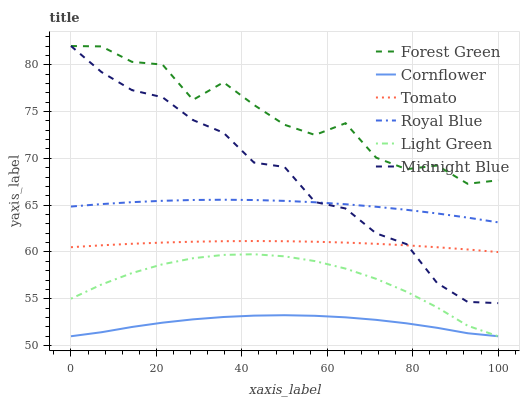Does Cornflower have the minimum area under the curve?
Answer yes or no. Yes. Does Forest Green have the maximum area under the curve?
Answer yes or no. Yes. Does Midnight Blue have the minimum area under the curve?
Answer yes or no. No. Does Midnight Blue have the maximum area under the curve?
Answer yes or no. No. Is Tomato the smoothest?
Answer yes or no. Yes. Is Forest Green the roughest?
Answer yes or no. Yes. Is Cornflower the smoothest?
Answer yes or no. No. Is Cornflower the roughest?
Answer yes or no. No. Does Midnight Blue have the lowest value?
Answer yes or no. No. Does Forest Green have the highest value?
Answer yes or no. Yes. Does Cornflower have the highest value?
Answer yes or no. No. Is Cornflower less than Royal Blue?
Answer yes or no. Yes. Is Forest Green greater than Royal Blue?
Answer yes or no. Yes. Does Cornflower intersect Light Green?
Answer yes or no. Yes. Is Cornflower less than Light Green?
Answer yes or no. No. Is Cornflower greater than Light Green?
Answer yes or no. No. Does Cornflower intersect Royal Blue?
Answer yes or no. No. 